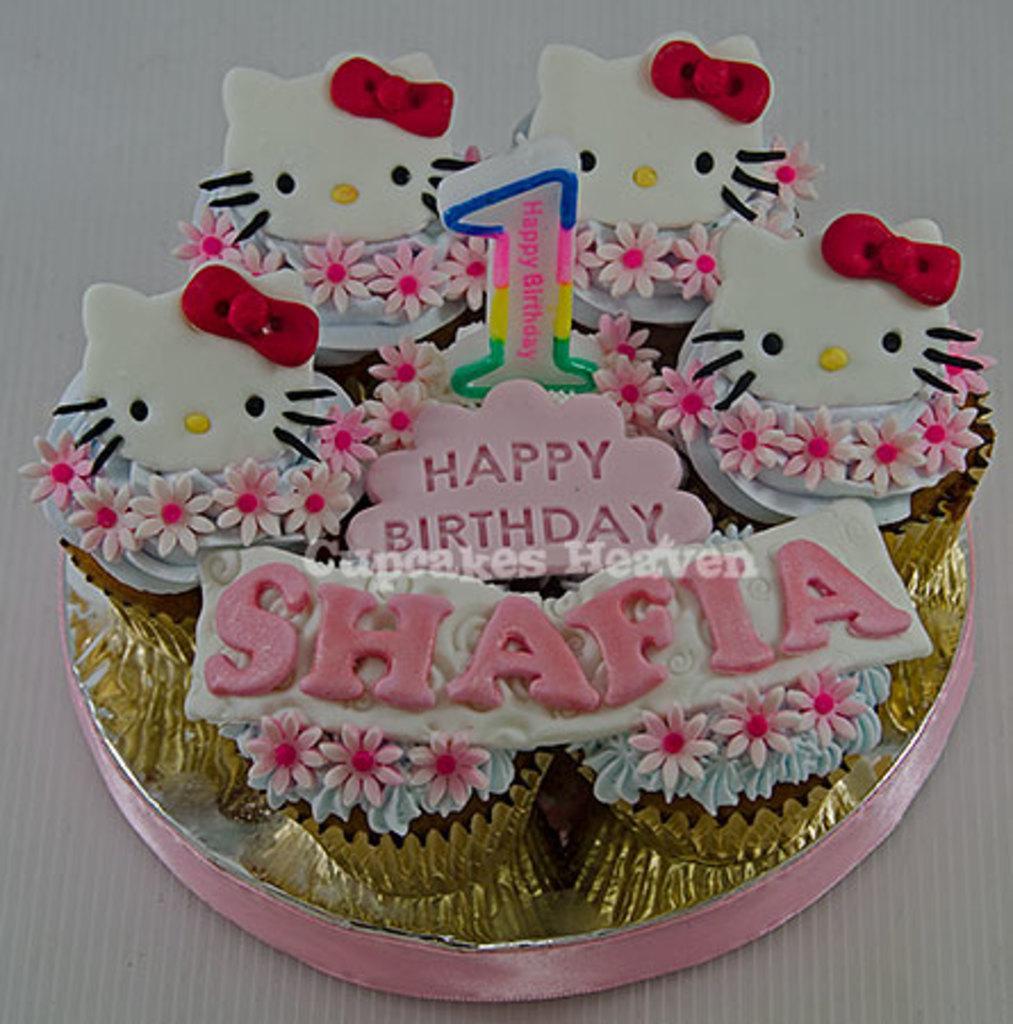Please provide a concise description of this image. In this image, I can see a birthday cake with a candle, which is placed on an object. At the center of the image, I can see the watermark. 